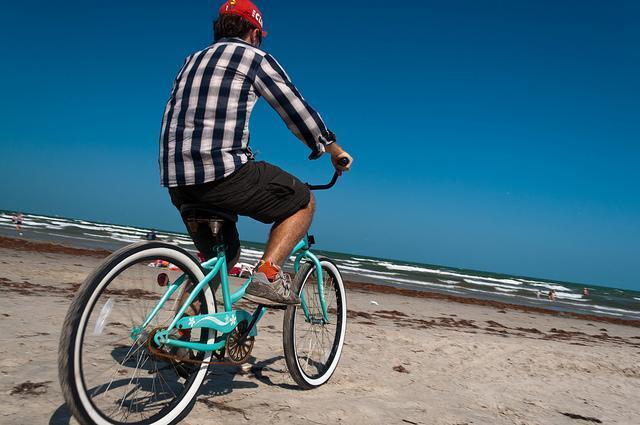How many people are in the photo?
Give a very brief answer. 1. 